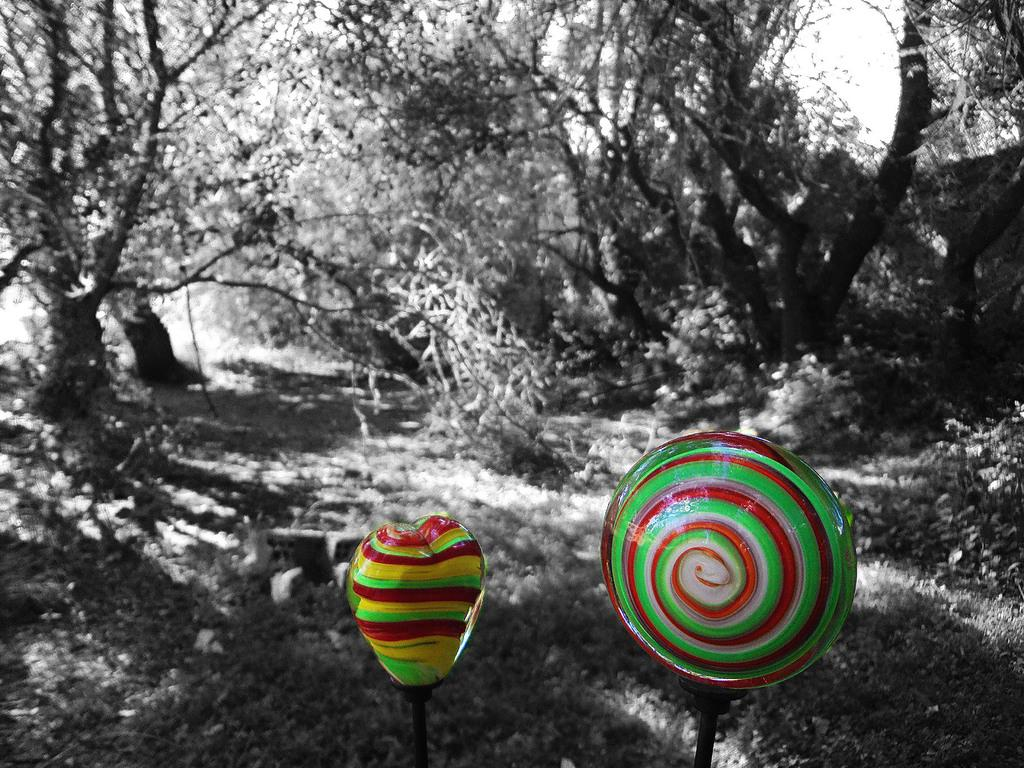What is located at the bottom of the image? There are candies at the bottom of the image. What can be seen in the background of the image? There are trees in the background of the image. What type of smile can be seen on the candies in the image? There are no smiles present in the image, as candies do not have facial expressions. 